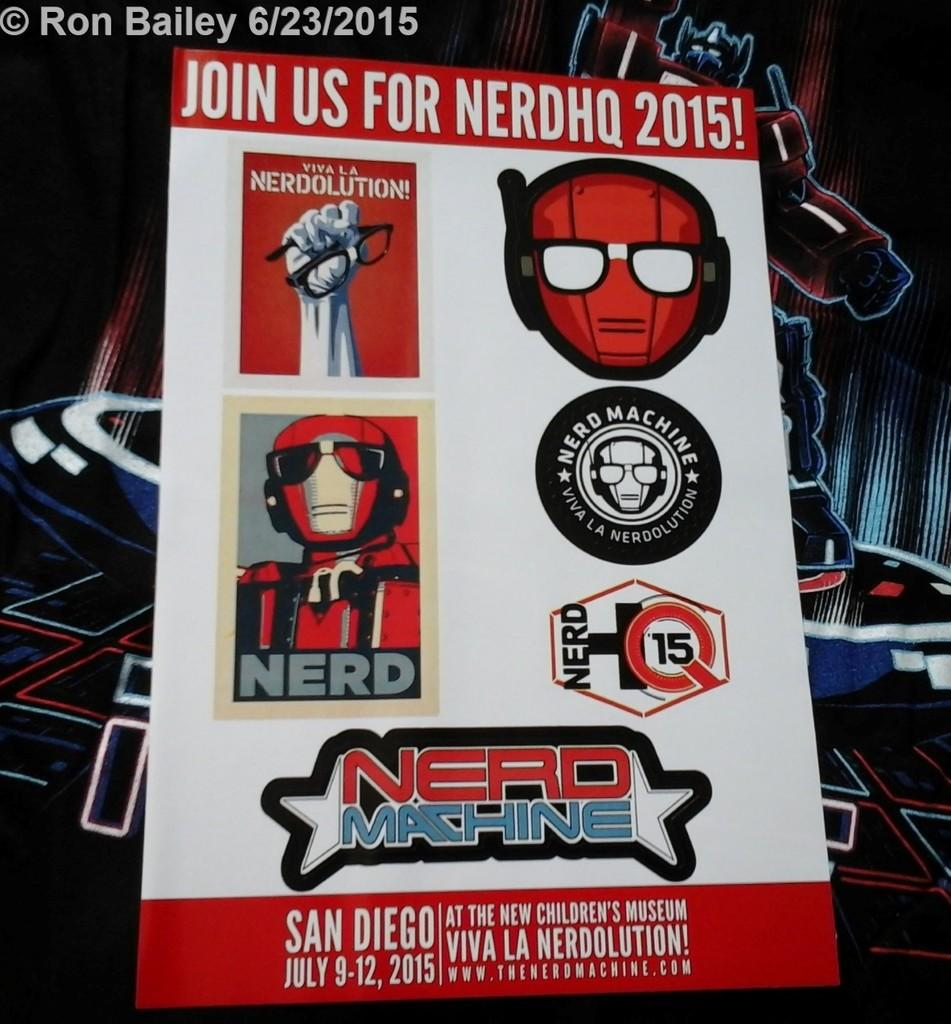<image>
Offer a succinct explanation of the picture presented. A nerd machine ad from san diego july 9-12 